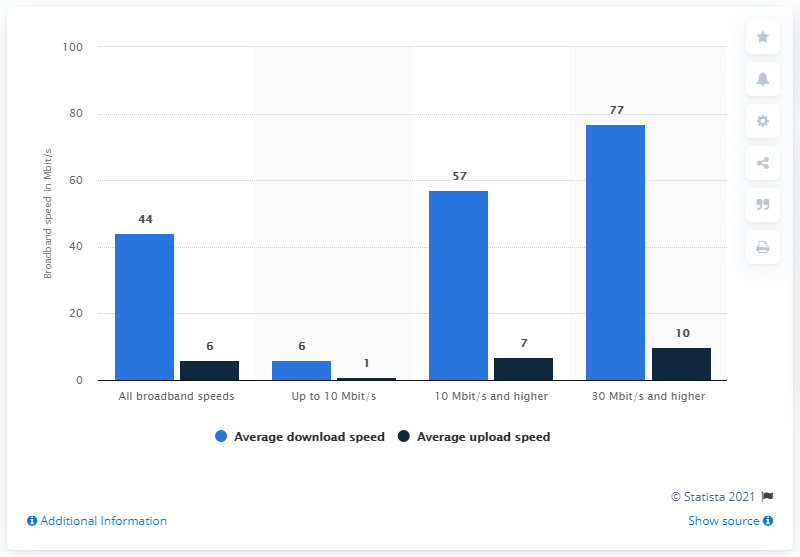Mention a couple of crucial points in this snapshot. Out of the total number of bars that have similar values, there are two. The color of the rightmost bar is navy blue. 